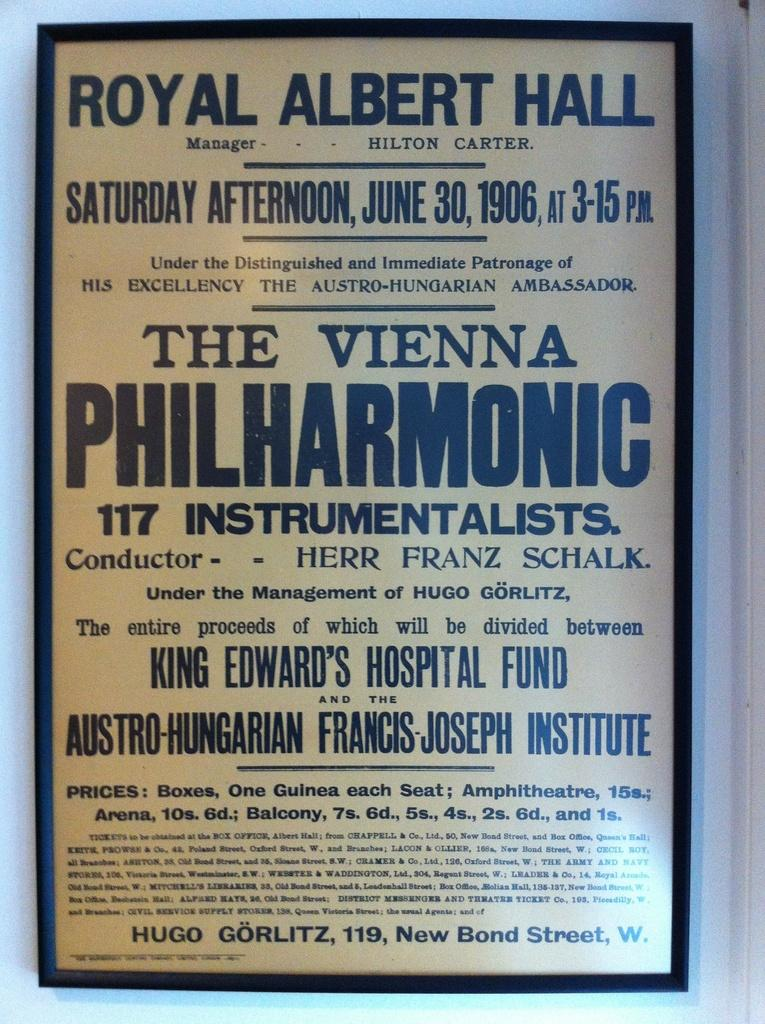<image>
Write a terse but informative summary of the picture. The Vienna Philharmonic took place on Saturday June 30, 1906 at 3:15 PM. 